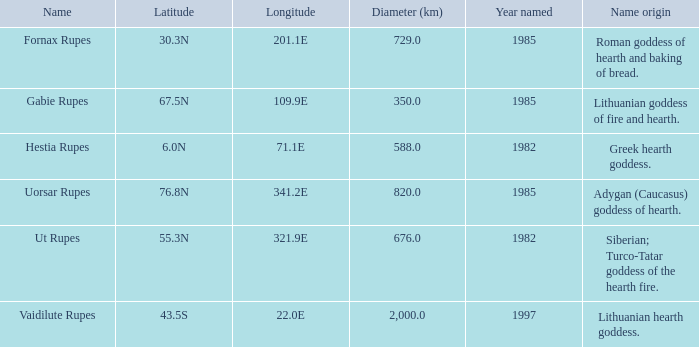What is the latitude of vaidilute rupes? 43.5S. 